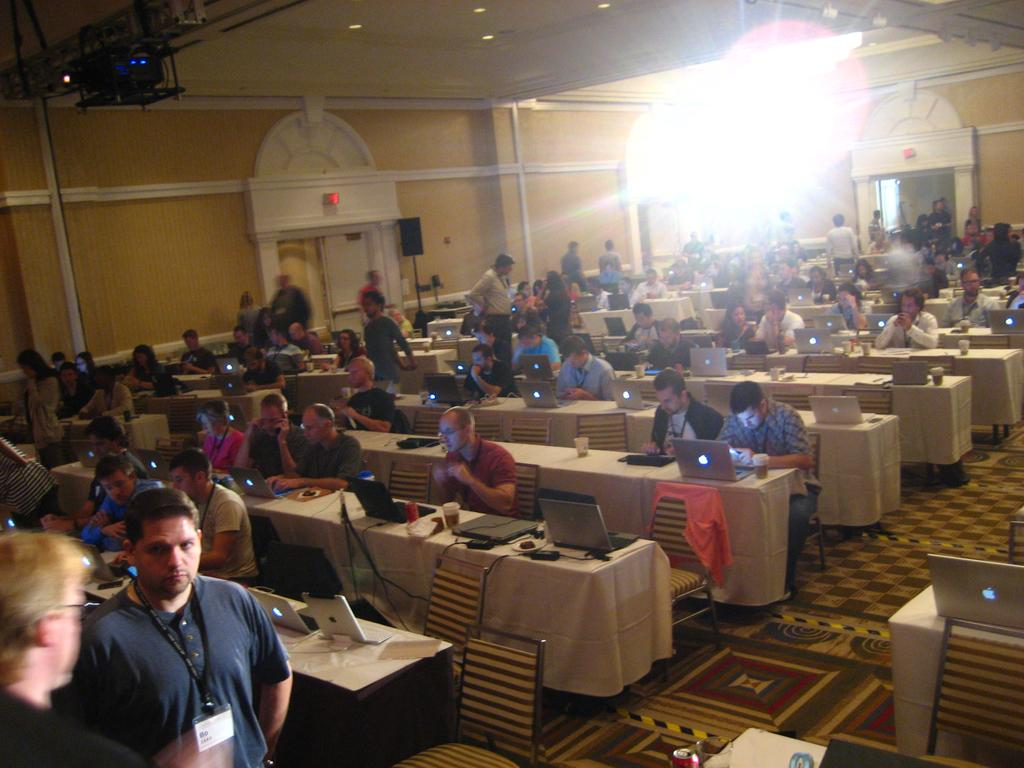What is happening in the image involving the group of people? The people in the image are working. What are the people using to support their posture while working? The people are sitting on chairs. Can you describe the position of the person on the left side of the group? There is a person standing on the left side of the group. What type of bone is visible in the image? There is no bone present in the image. Are the people in the image sleeping? No, the people in the image are working, not sleeping. 